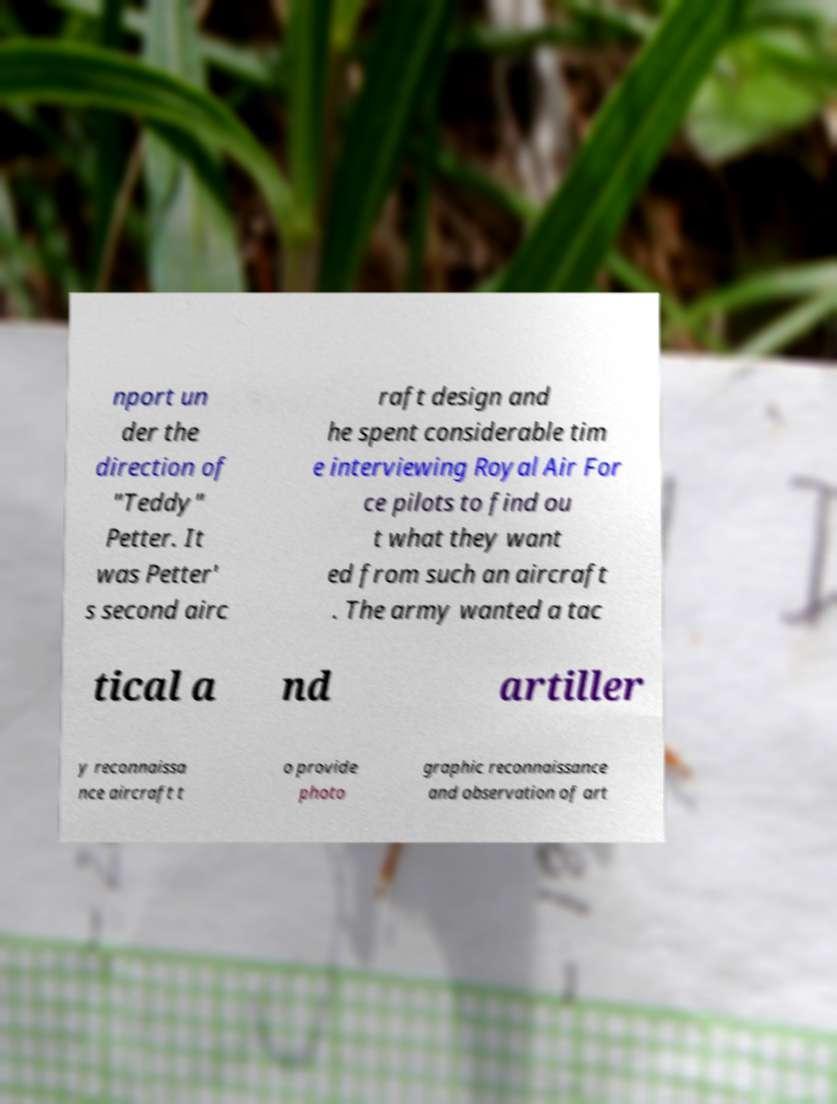Can you read and provide the text displayed in the image?This photo seems to have some interesting text. Can you extract and type it out for me? nport un der the direction of "Teddy" Petter. It was Petter' s second airc raft design and he spent considerable tim e interviewing Royal Air For ce pilots to find ou t what they want ed from such an aircraft . The army wanted a tac tical a nd artiller y reconnaissa nce aircraft t o provide photo graphic reconnaissance and observation of art 